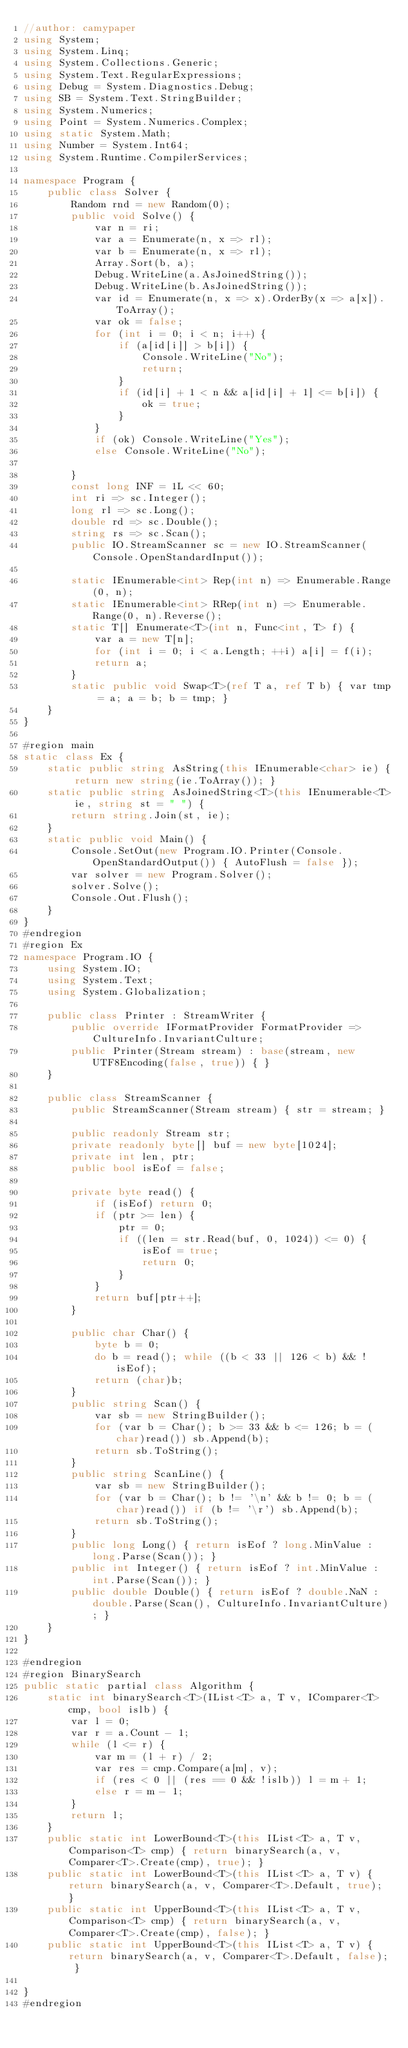<code> <loc_0><loc_0><loc_500><loc_500><_C#_>//author: camypaper
using System;
using System.Linq;
using System.Collections.Generic;
using System.Text.RegularExpressions;
using Debug = System.Diagnostics.Debug;
using SB = System.Text.StringBuilder;
using System.Numerics;
using Point = System.Numerics.Complex;
using static System.Math;
using Number = System.Int64;
using System.Runtime.CompilerServices;

namespace Program {
    public class Solver {
        Random rnd = new Random(0);
        public void Solve() {
            var n = ri;
            var a = Enumerate(n, x => rl);
            var b = Enumerate(n, x => rl);
            Array.Sort(b, a);
            Debug.WriteLine(a.AsJoinedString());
            Debug.WriteLine(b.AsJoinedString());
            var id = Enumerate(n, x => x).OrderBy(x => a[x]).ToArray();
            var ok = false;
            for (int i = 0; i < n; i++) {
                if (a[id[i]] > b[i]) {
                    Console.WriteLine("No");
                    return;
                }
                if (id[i] + 1 < n && a[id[i] + 1] <= b[i]) {
                    ok = true;
                }
            }
            if (ok) Console.WriteLine("Yes");
            else Console.WriteLine("No");

        }
        const long INF = 1L << 60;
        int ri => sc.Integer();
        long rl => sc.Long();
        double rd => sc.Double();
        string rs => sc.Scan();
        public IO.StreamScanner sc = new IO.StreamScanner(Console.OpenStandardInput());

        static IEnumerable<int> Rep(int n) => Enumerable.Range(0, n);
        static IEnumerable<int> RRep(int n) => Enumerable.Range(0, n).Reverse();
        static T[] Enumerate<T>(int n, Func<int, T> f) {
            var a = new T[n];
            for (int i = 0; i < a.Length; ++i) a[i] = f(i);
            return a;
        }
        static public void Swap<T>(ref T a, ref T b) { var tmp = a; a = b; b = tmp; }
    }
}

#region main
static class Ex {
    static public string AsString(this IEnumerable<char> ie) { return new string(ie.ToArray()); }
    static public string AsJoinedString<T>(this IEnumerable<T> ie, string st = " ") {
        return string.Join(st, ie);
    }
    static public void Main() {
        Console.SetOut(new Program.IO.Printer(Console.OpenStandardOutput()) { AutoFlush = false });
        var solver = new Program.Solver();
        solver.Solve();
        Console.Out.Flush();
    }
}
#endregion
#region Ex
namespace Program.IO {
    using System.IO;
    using System.Text;
    using System.Globalization;

    public class Printer : StreamWriter {
        public override IFormatProvider FormatProvider => CultureInfo.InvariantCulture;
        public Printer(Stream stream) : base(stream, new UTF8Encoding(false, true)) { }
    }

    public class StreamScanner {
        public StreamScanner(Stream stream) { str = stream; }

        public readonly Stream str;
        private readonly byte[] buf = new byte[1024];
        private int len, ptr;
        public bool isEof = false;

        private byte read() {
            if (isEof) return 0;
            if (ptr >= len) {
                ptr = 0;
                if ((len = str.Read(buf, 0, 1024)) <= 0) {
                    isEof = true;
                    return 0;
                }
            }
            return buf[ptr++];
        }

        public char Char() {
            byte b = 0;
            do b = read(); while ((b < 33 || 126 < b) && !isEof);
            return (char)b;
        }
        public string Scan() {
            var sb = new StringBuilder();
            for (var b = Char(); b >= 33 && b <= 126; b = (char)read()) sb.Append(b);
            return sb.ToString();
        }
        public string ScanLine() {
            var sb = new StringBuilder();
            for (var b = Char(); b != '\n' && b != 0; b = (char)read()) if (b != '\r') sb.Append(b);
            return sb.ToString();
        }
        public long Long() { return isEof ? long.MinValue : long.Parse(Scan()); }
        public int Integer() { return isEof ? int.MinValue : int.Parse(Scan()); }
        public double Double() { return isEof ? double.NaN : double.Parse(Scan(), CultureInfo.InvariantCulture); }
    }
}

#endregion
#region BinarySearch
public static partial class Algorithm {
    static int binarySearch<T>(IList<T> a, T v, IComparer<T> cmp, bool islb) {
        var l = 0;
        var r = a.Count - 1;
        while (l <= r) {
            var m = (l + r) / 2;
            var res = cmp.Compare(a[m], v);
            if (res < 0 || (res == 0 && !islb)) l = m + 1;
            else r = m - 1;
        }
        return l;
    }
    public static int LowerBound<T>(this IList<T> a, T v, Comparison<T> cmp) { return binarySearch(a, v, Comparer<T>.Create(cmp), true); }
    public static int LowerBound<T>(this IList<T> a, T v) { return binarySearch(a, v, Comparer<T>.Default, true); }
    public static int UpperBound<T>(this IList<T> a, T v, Comparison<T> cmp) { return binarySearch(a, v, Comparer<T>.Create(cmp), false); }
    public static int UpperBound<T>(this IList<T> a, T v) { return binarySearch(a, v, Comparer<T>.Default, false); }

}
#endregion

</code> 